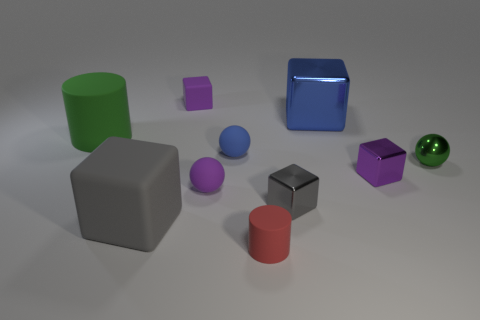What size is the matte sphere that is the same color as the large metal thing?
Make the answer very short. Small. Is the material of the purple object behind the tiny purple metallic object the same as the blue block?
Provide a succinct answer. No. There is a large object that is behind the matte cylinder that is to the left of the cylinder in front of the small gray thing; what shape is it?
Make the answer very short. Cube. There is a thing that is the same color as the metallic ball; what shape is it?
Keep it short and to the point. Cylinder. How many red matte things have the same size as the blue matte thing?
Keep it short and to the point. 1. Is there a object on the right side of the big cube that is on the left side of the gray shiny cube?
Your answer should be very brief. Yes. How many things are either big blue shiny things or big green matte spheres?
Your answer should be compact. 1. The cylinder to the right of the purple object that is behind the metal object that is behind the small shiny sphere is what color?
Provide a short and direct response. Red. Is there any other thing that is the same color as the large metal cube?
Provide a short and direct response. Yes. Does the green shiny ball have the same size as the red thing?
Keep it short and to the point. Yes. 